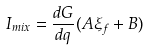Convert formula to latex. <formula><loc_0><loc_0><loc_500><loc_500>I _ { m i x } = \frac { d G } { d q } ( A \xi _ { f } + B )</formula> 